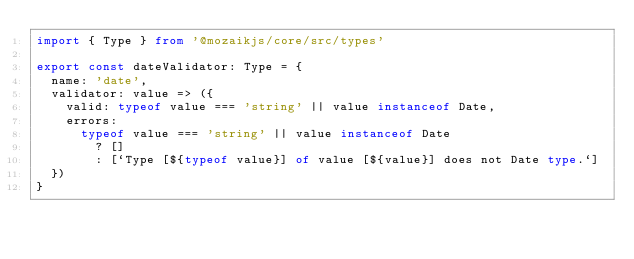<code> <loc_0><loc_0><loc_500><loc_500><_TypeScript_>import { Type } from '@mozaikjs/core/src/types'

export const dateValidator: Type = {
  name: 'date',
  validator: value => ({
    valid: typeof value === 'string' || value instanceof Date,
    errors:
      typeof value === 'string' || value instanceof Date
        ? []
        : [`Type [${typeof value}] of value [${value}] does not Date type.`]
  })
}


</code> 